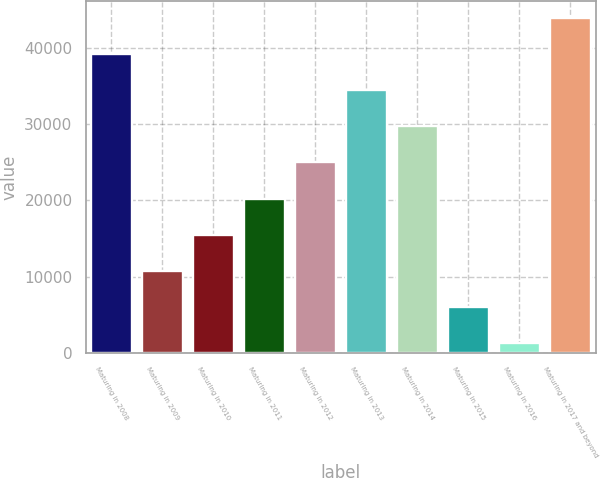<chart> <loc_0><loc_0><loc_500><loc_500><bar_chart><fcel>Maturing in 2008<fcel>Maturing in 2009<fcel>Maturing in 2010<fcel>Maturing in 2011<fcel>Maturing in 2012<fcel>Maturing in 2013<fcel>Maturing in 2014<fcel>Maturing in 2015<fcel>Maturing in 2016<fcel>Maturing in 2017 and beyond<nl><fcel>39236<fcel>10748<fcel>15496<fcel>20244<fcel>24992<fcel>34488<fcel>29740<fcel>6000<fcel>1252<fcel>43984<nl></chart> 